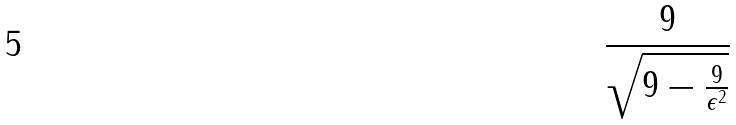Convert formula to latex. <formula><loc_0><loc_0><loc_500><loc_500>\frac { 9 } { \sqrt { 9 - \frac { 9 } { \epsilon ^ { 2 } } } }</formula> 